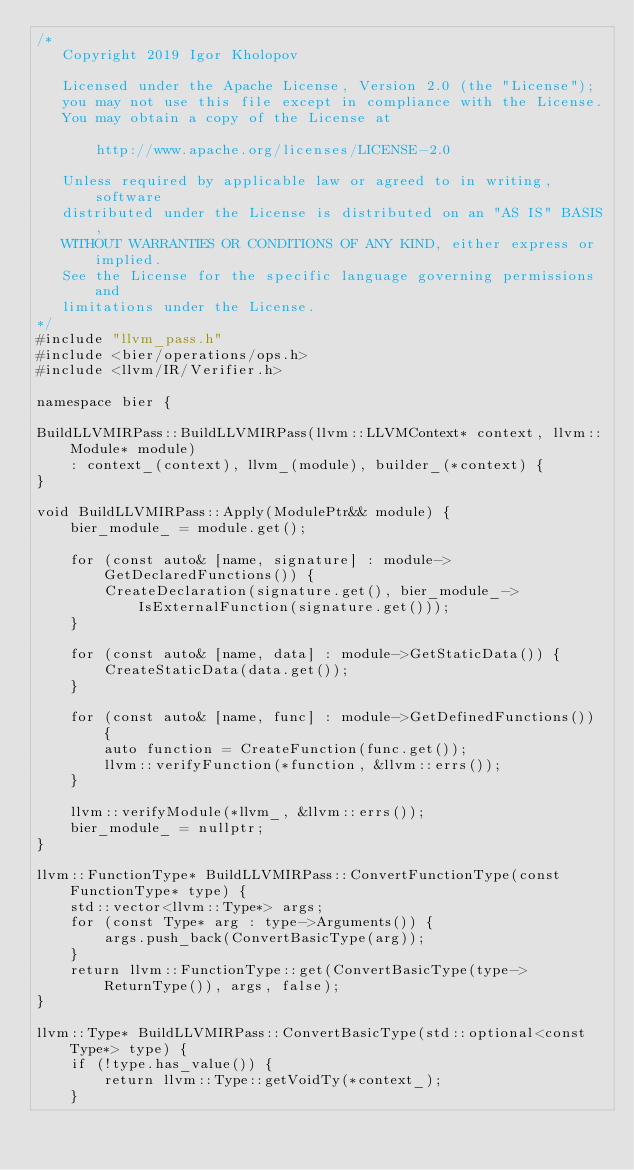<code> <loc_0><loc_0><loc_500><loc_500><_C++_>/*
   Copyright 2019 Igor Kholopov

   Licensed under the Apache License, Version 2.0 (the "License");
   you may not use this file except in compliance with the License.
   You may obtain a copy of the License at

       http://www.apache.org/licenses/LICENSE-2.0

   Unless required by applicable law or agreed to in writing, software
   distributed under the License is distributed on an "AS IS" BASIS,
   WITHOUT WARRANTIES OR CONDITIONS OF ANY KIND, either express or implied.
   See the License for the specific language governing permissions and
   limitations under the License.
*/
#include "llvm_pass.h"
#include <bier/operations/ops.h>
#include <llvm/IR/Verifier.h>

namespace bier {

BuildLLVMIRPass::BuildLLVMIRPass(llvm::LLVMContext* context, llvm::Module* module)
    : context_(context), llvm_(module), builder_(*context) {
}

void BuildLLVMIRPass::Apply(ModulePtr&& module) {
    bier_module_ = module.get();

    for (const auto& [name, signature] : module->GetDeclaredFunctions()) {
        CreateDeclaration(signature.get(), bier_module_->IsExternalFunction(signature.get()));
    }

    for (const auto& [name, data] : module->GetStaticData()) {
        CreateStaticData(data.get());
    }

    for (const auto& [name, func] : module->GetDefinedFunctions()) {
        auto function = CreateFunction(func.get());
        llvm::verifyFunction(*function, &llvm::errs());
    }

    llvm::verifyModule(*llvm_, &llvm::errs());
    bier_module_ = nullptr;
}

llvm::FunctionType* BuildLLVMIRPass::ConvertFunctionType(const FunctionType* type) {
    std::vector<llvm::Type*> args;
    for (const Type* arg : type->Arguments()) {
        args.push_back(ConvertBasicType(arg));
    }
    return llvm::FunctionType::get(ConvertBasicType(type->ReturnType()), args, false);
}

llvm::Type* BuildLLVMIRPass::ConvertBasicType(std::optional<const Type*> type) {
    if (!type.has_value()) {
        return llvm::Type::getVoidTy(*context_);
    }</code> 